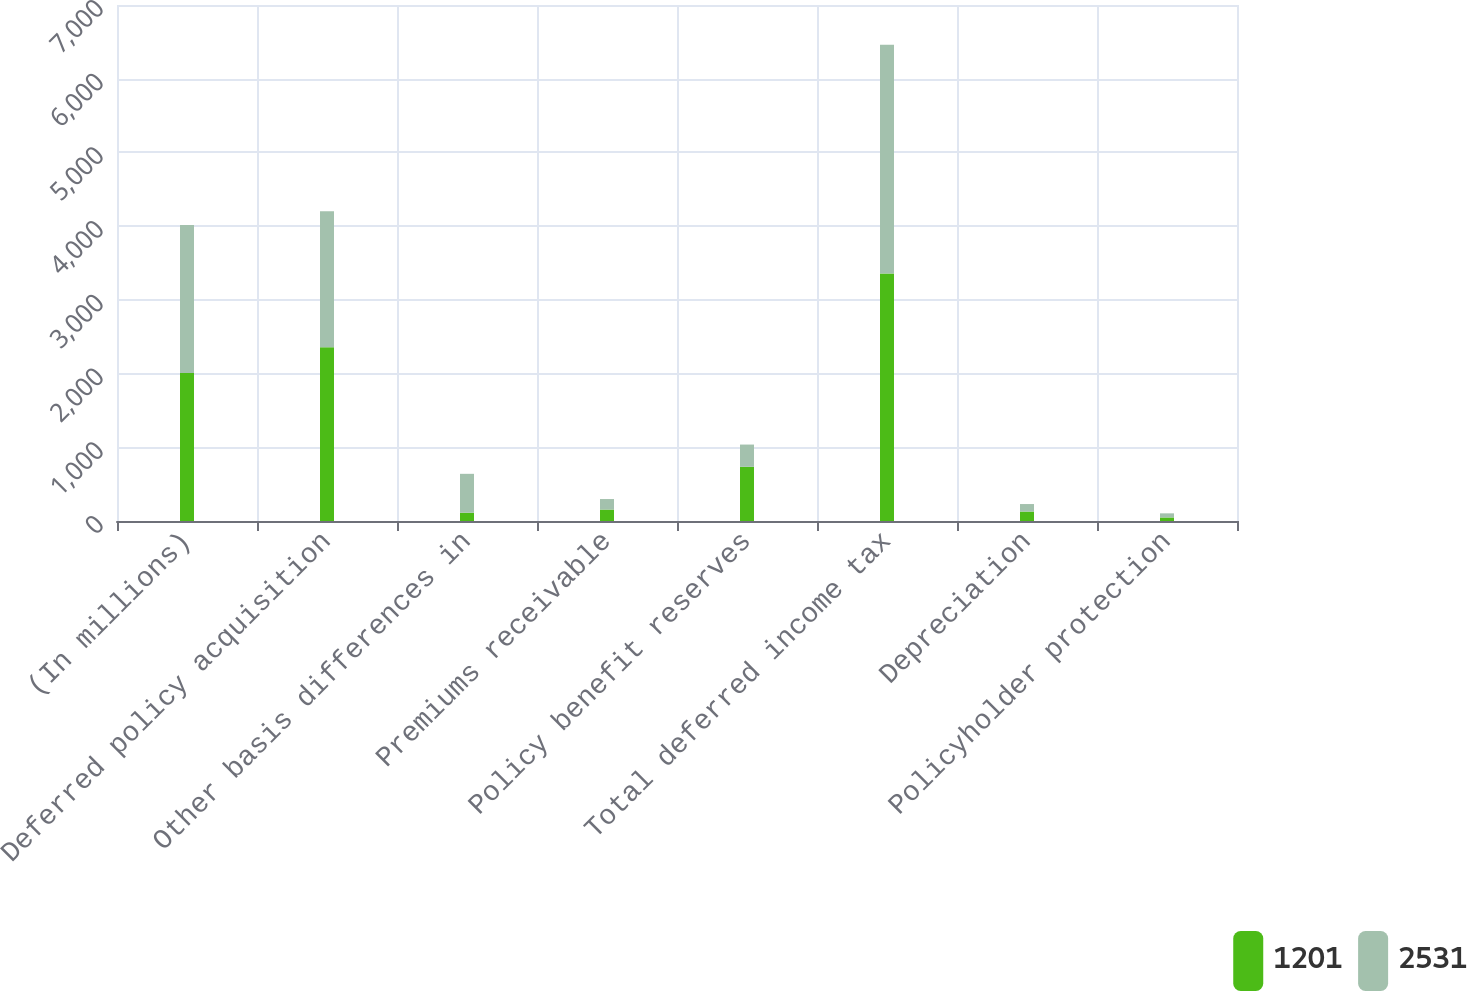Convert chart to OTSL. <chart><loc_0><loc_0><loc_500><loc_500><stacked_bar_chart><ecel><fcel>(In millions)<fcel>Deferred policy acquisition<fcel>Other basis differences in<fcel>Premiums receivable<fcel>Policy benefit reserves<fcel>Total deferred income tax<fcel>Depreciation<fcel>Policyholder protection<nl><fcel>1201<fcel>2008<fcel>2356<fcel>112<fcel>155<fcel>735<fcel>3358<fcel>128<fcel>48<nl><fcel>2531<fcel>2007<fcel>1847<fcel>528<fcel>143<fcel>302<fcel>3103<fcel>102<fcel>56<nl></chart> 